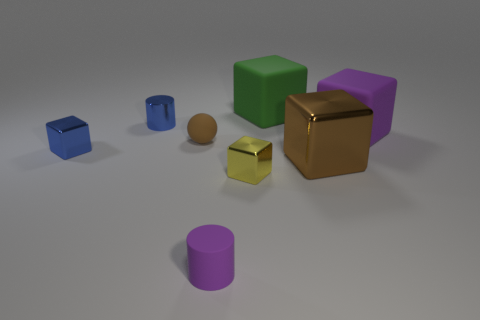Subtract all small yellow blocks. How many blocks are left? 4 Subtract 1 blocks. How many blocks are left? 4 Subtract all yellow cubes. How many cubes are left? 4 Add 1 cylinders. How many objects exist? 9 Subtract all brown blocks. Subtract all yellow balls. How many blocks are left? 4 Subtract all cylinders. How many objects are left? 6 Subtract 0 red blocks. How many objects are left? 8 Subtract all small green matte cylinders. Subtract all small metallic things. How many objects are left? 5 Add 4 brown rubber balls. How many brown rubber balls are left? 5 Add 4 blue things. How many blue things exist? 6 